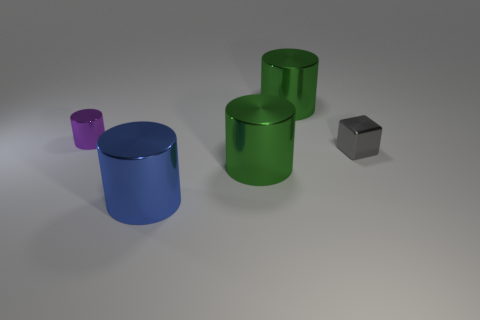Subtract 1 cylinders. How many cylinders are left? 3 Add 3 tiny gray things. How many objects exist? 8 Subtract all cylinders. How many objects are left? 1 Subtract 0 cyan balls. How many objects are left? 5 Subtract all large red metal cubes. Subtract all tiny things. How many objects are left? 3 Add 4 purple cylinders. How many purple cylinders are left? 5 Add 5 large green objects. How many large green objects exist? 7 